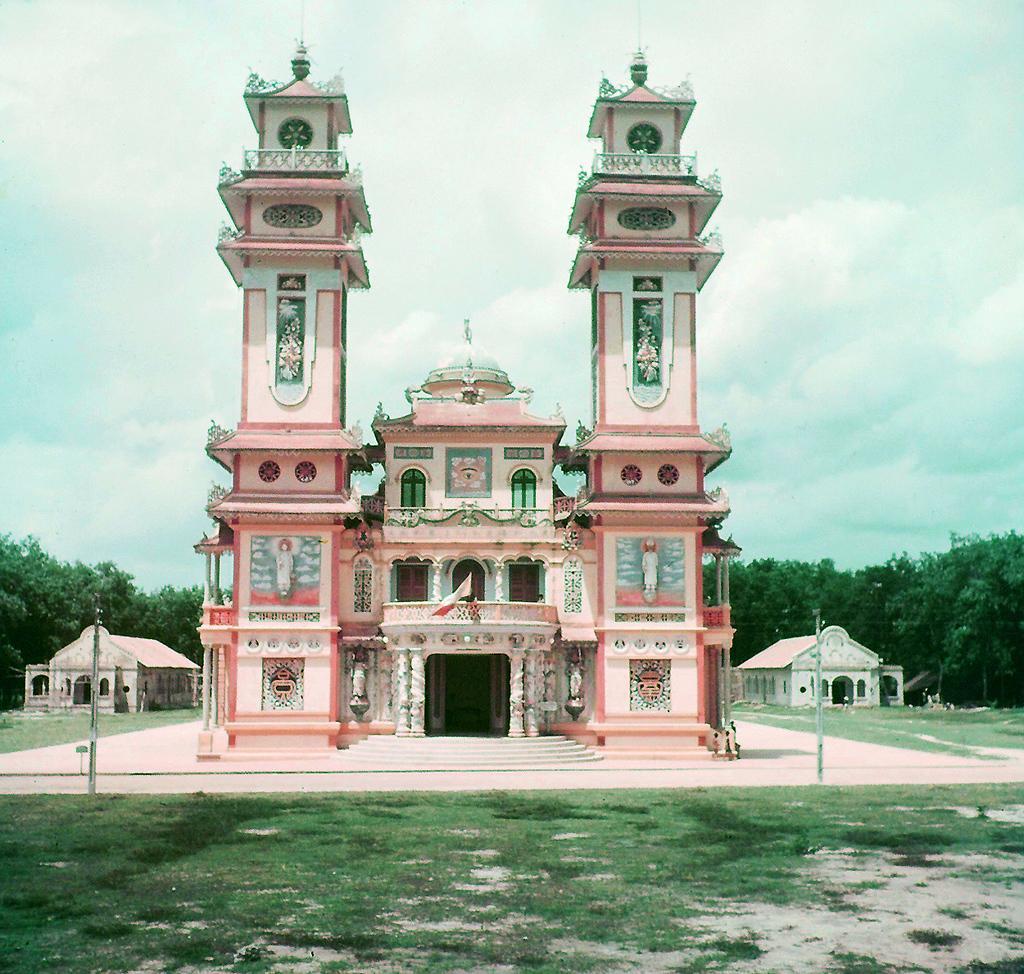Can you describe this image briefly? In this picture I can observe a building. This building is in pink color. There is some grass on the land in front of this building. In the background there are trees and a sky with some clouds. 